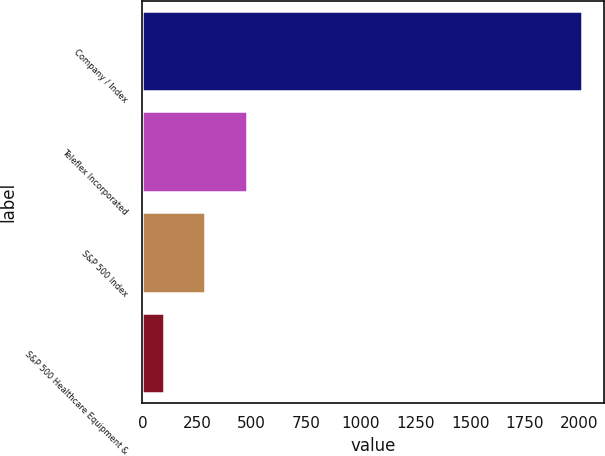Convert chart to OTSL. <chart><loc_0><loc_0><loc_500><loc_500><bar_chart><fcel>Company / Index<fcel>Teleflex Incorporated<fcel>S&P 500 Index<fcel>S&P 500 Healthcare Equipment &<nl><fcel>2011<fcel>479.8<fcel>288.4<fcel>97<nl></chart> 